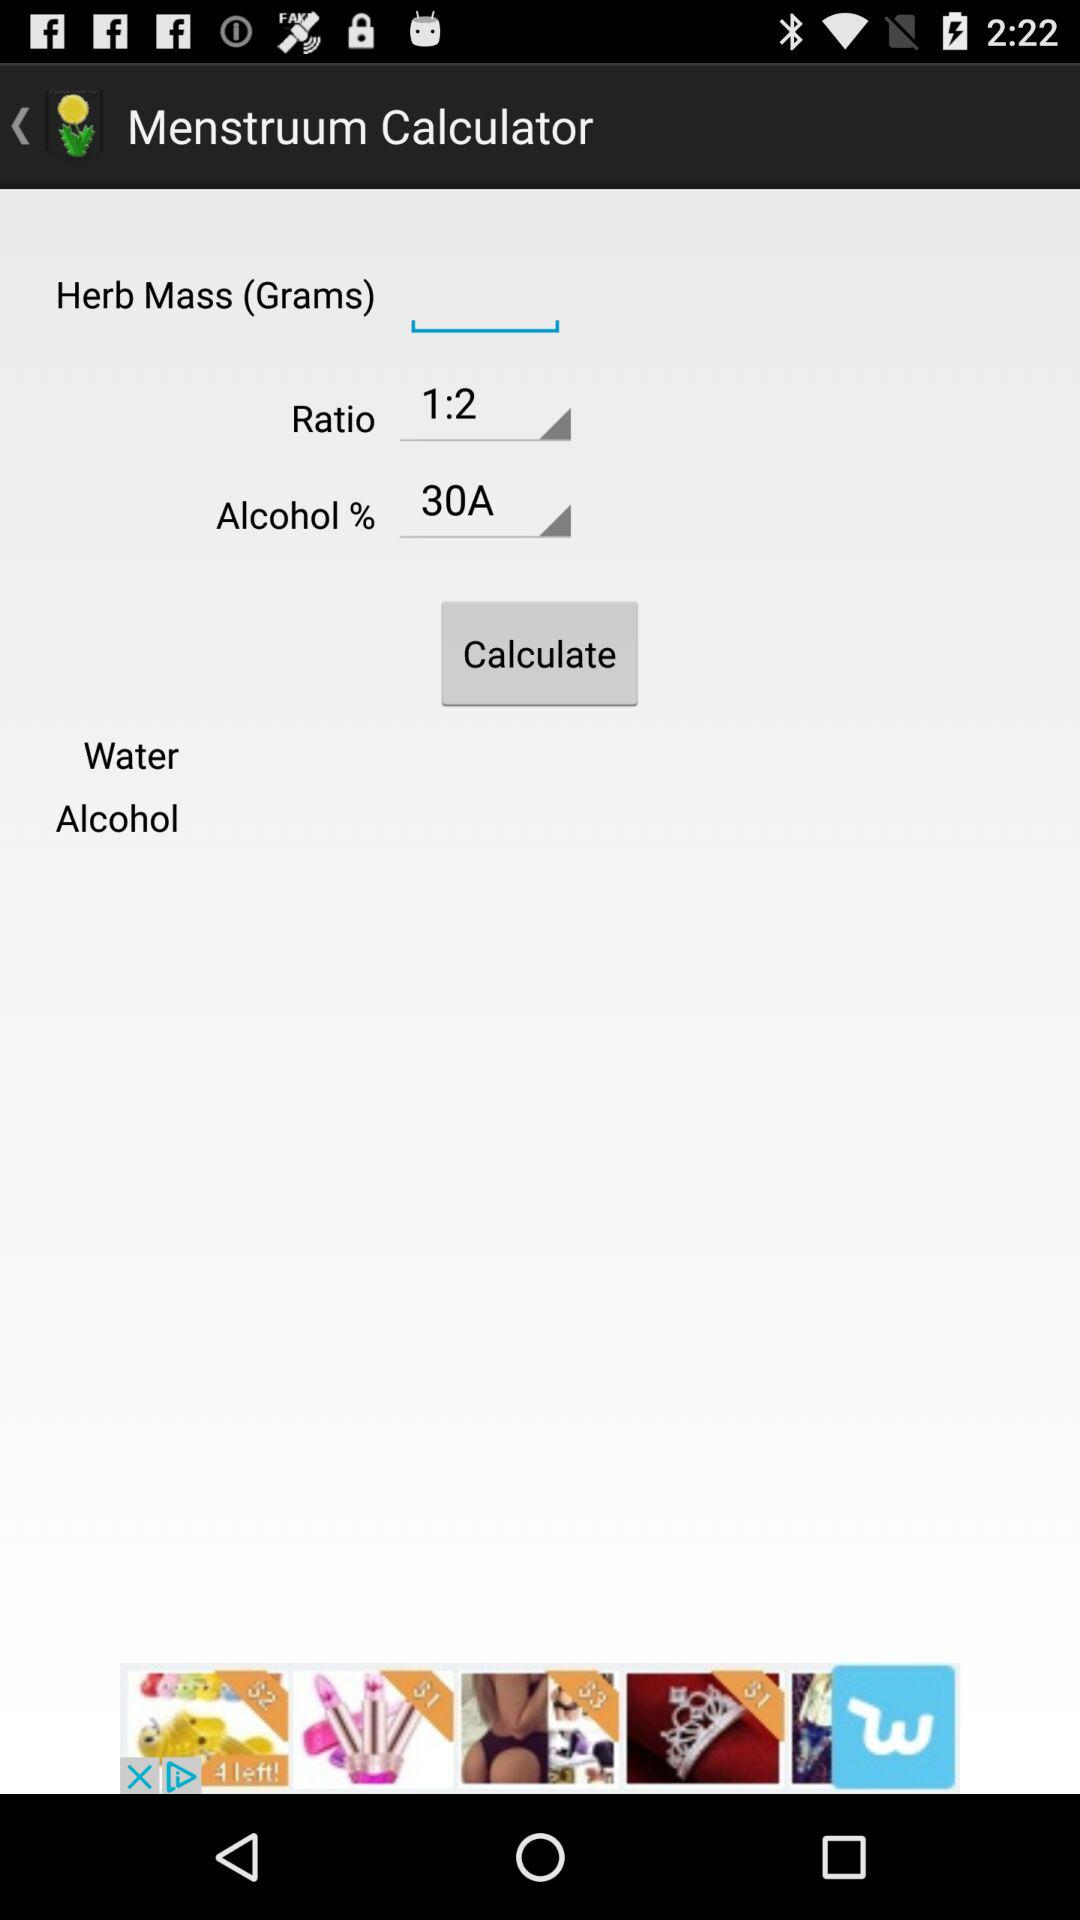What is the selected ratio? The selected ratio is 1:2. 